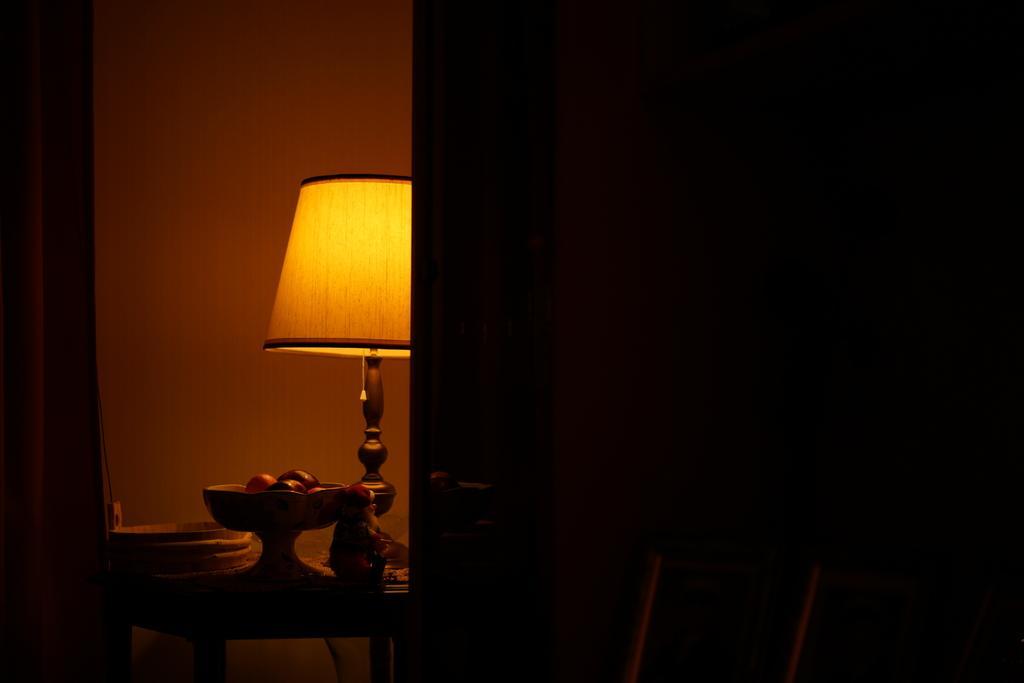How would you summarize this image in a sentence or two? On this table there is a lamp, toy and things. 